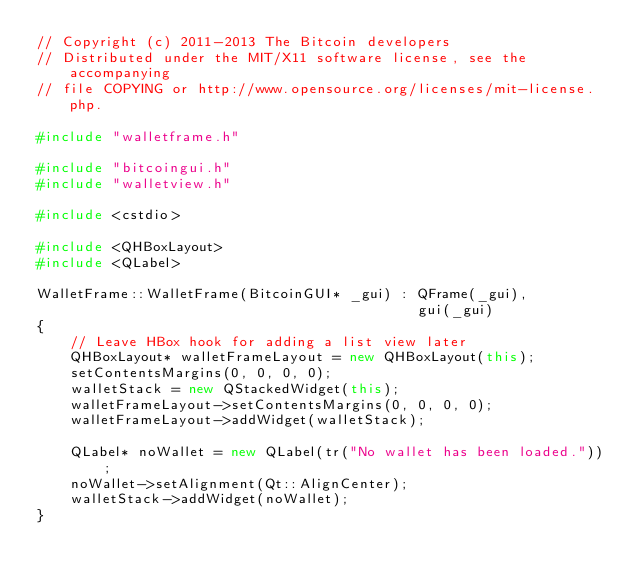<code> <loc_0><loc_0><loc_500><loc_500><_C++_>// Copyright (c) 2011-2013 The Bitcoin developers
// Distributed under the MIT/X11 software license, see the accompanying
// file COPYING or http://www.opensource.org/licenses/mit-license.php.

#include "walletframe.h"

#include "bitcoingui.h"
#include "walletview.h"

#include <cstdio>

#include <QHBoxLayout>
#include <QLabel>

WalletFrame::WalletFrame(BitcoinGUI* _gui) : QFrame(_gui),
                                             gui(_gui)
{
    // Leave HBox hook for adding a list view later
    QHBoxLayout* walletFrameLayout = new QHBoxLayout(this);
    setContentsMargins(0, 0, 0, 0);
    walletStack = new QStackedWidget(this);
    walletFrameLayout->setContentsMargins(0, 0, 0, 0);
    walletFrameLayout->addWidget(walletStack);

    QLabel* noWallet = new QLabel(tr("No wallet has been loaded."));
    noWallet->setAlignment(Qt::AlignCenter);
    walletStack->addWidget(noWallet);
}
</code> 